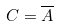Convert formula to latex. <formula><loc_0><loc_0><loc_500><loc_500>C = \overline { A }</formula> 